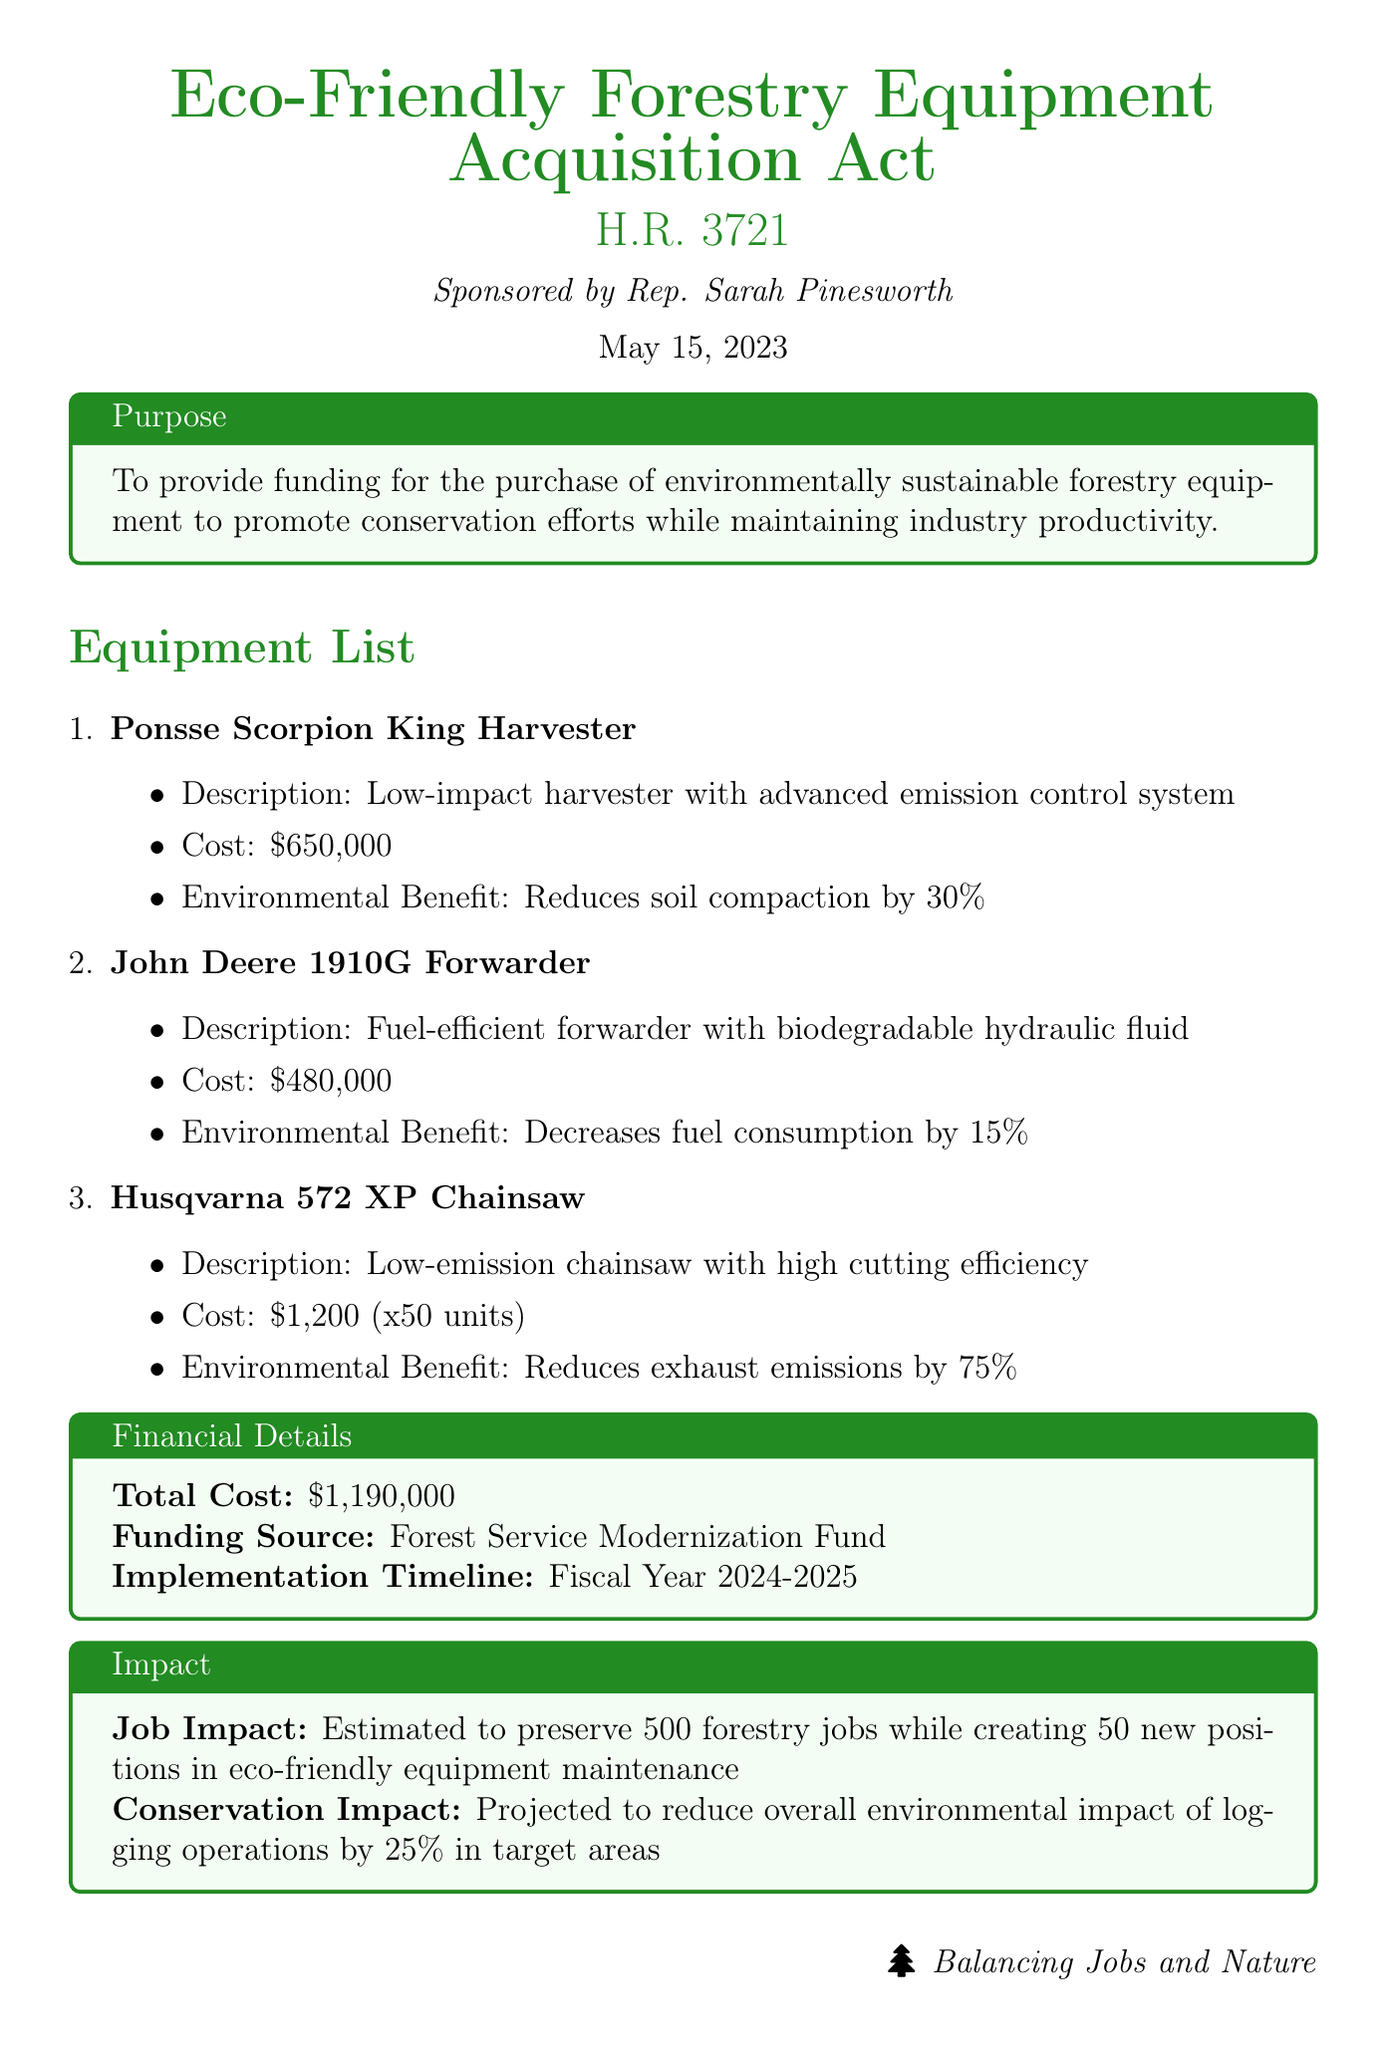What is the title of the bill? The title of the bill is found in the first part of the document.
Answer: Eco-Friendly Forestry Equipment Acquisition Act Who sponsored the bill? The sponsor of the bill is mentioned directly after the title.
Answer: Rep. Sarah Pinesworth What is the total cost of the equipment? The total cost is specified in the Financial Details section.
Answer: $1,190,000 How many forestry jobs are estimated to be preserved? This information is given in the Impact section of the document.
Answer: 500 What benefit does the Ponsse Scorpion King Harvester provide? The environmental benefit of this harvester is described in the Equipment List.
Answer: Reduces soil compaction by 30% What is the funding source for the bill? The funding source is listed in the Financial Details section.
Answer: Forest Service Modernization Fund What is the projected reduction in environmental impact of logging operations? This projection is given in the Impact section of the document.
Answer: 25% What is the implementation timeline of the bill? The timeline for implementation is stated in the Financial Details section.
Answer: Fiscal Year 2024-2025 